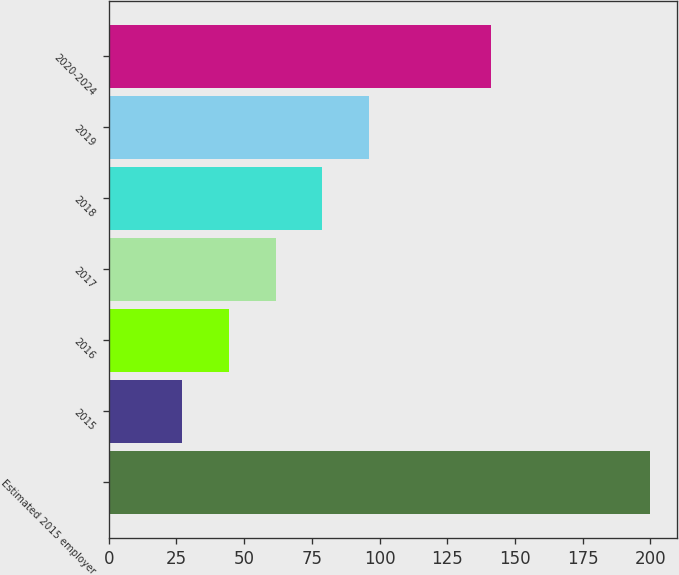Convert chart. <chart><loc_0><loc_0><loc_500><loc_500><bar_chart><fcel>Estimated 2015 employer<fcel>2015<fcel>2016<fcel>2017<fcel>2018<fcel>2019<fcel>2020-2024<nl><fcel>200<fcel>27<fcel>44.3<fcel>61.6<fcel>78.9<fcel>96.2<fcel>141<nl></chart> 